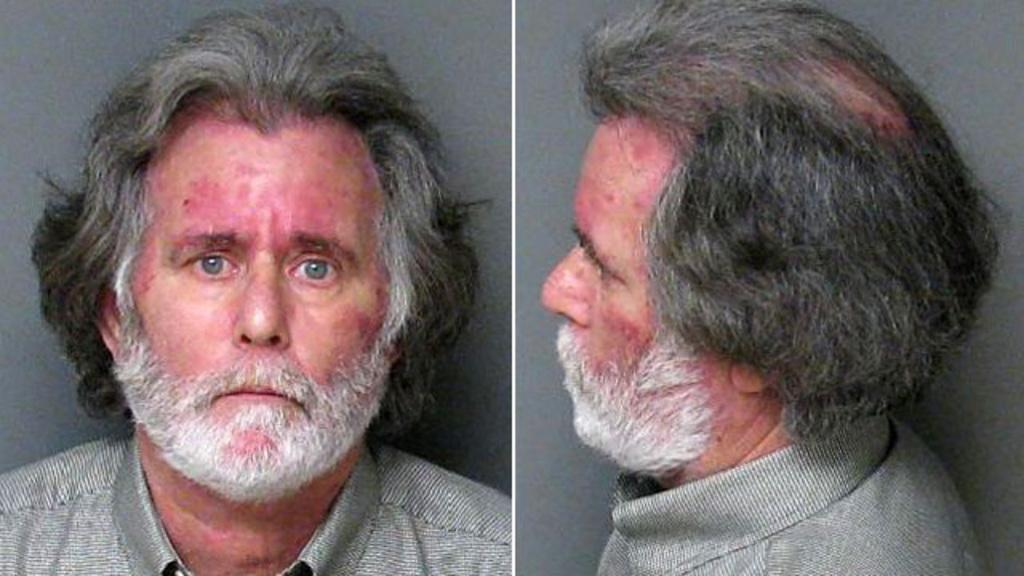What type of artwork is depicted in the image? The image is a collage. What is the main subject of the collage? The collage features a person. What type of rabbit can be seen interacting with the person in the image? There is no rabbit present in the image; it features a person in a collage. What type of power source is used to create the collage? The collage is a static image, so there is no power source involved in its creation. 